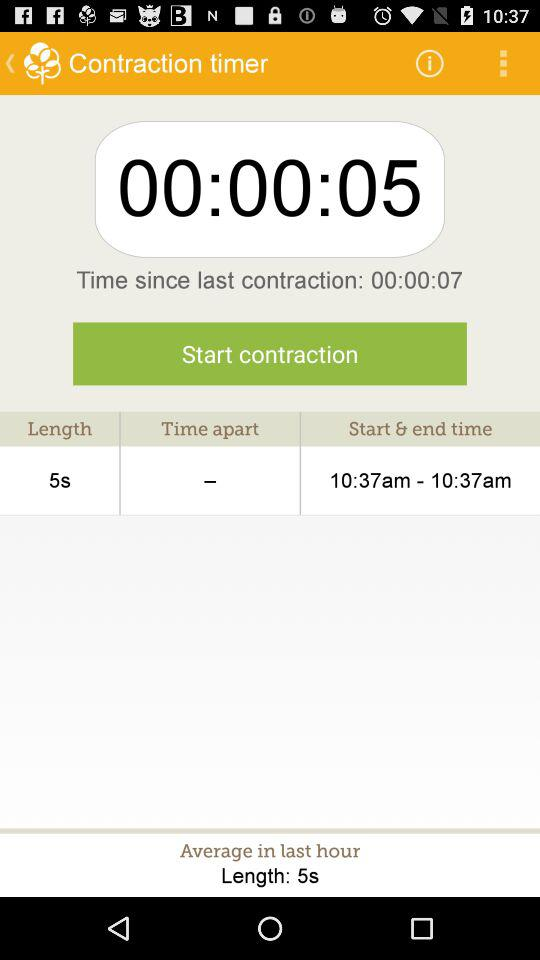How much time has passed since the last contraction? The time that has passed since the last contraction is 7 seconds. 